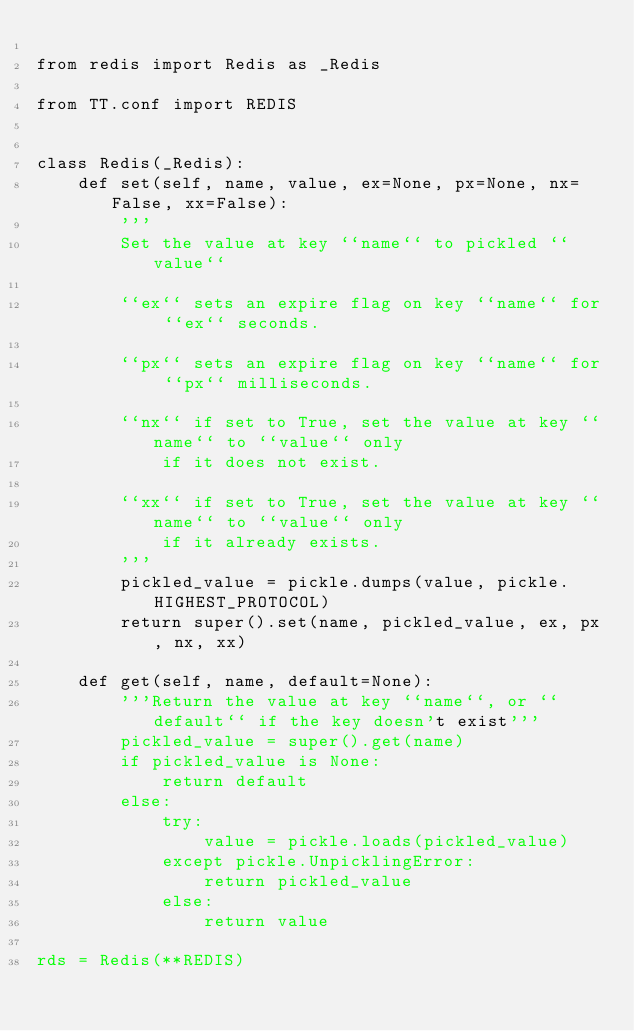<code> <loc_0><loc_0><loc_500><loc_500><_Python_>
from redis import Redis as _Redis

from TT.conf import REDIS


class Redis(_Redis):
    def set(self, name, value, ex=None, px=None, nx=False, xx=False):
        '''
        Set the value at key ``name`` to pickled ``value``

        ``ex`` sets an expire flag on key ``name`` for ``ex`` seconds.

        ``px`` sets an expire flag on key ``name`` for ``px`` milliseconds.

        ``nx`` if set to True, set the value at key ``name`` to ``value`` only
            if it does not exist.

        ``xx`` if set to True, set the value at key ``name`` to ``value`` only
            if it already exists.
        '''
        pickled_value = pickle.dumps(value, pickle.HIGHEST_PROTOCOL)
        return super().set(name, pickled_value, ex, px, nx, xx)

    def get(self, name, default=None):
        '''Return the value at key ``name``, or ``default`` if the key doesn't exist'''
        pickled_value = super().get(name)
        if pickled_value is None:
            return default
        else:
            try:
                value = pickle.loads(pickled_value)
            except pickle.UnpicklingError:
                return pickled_value
            else:
                return value

rds = Redis(**REDIS)</code> 